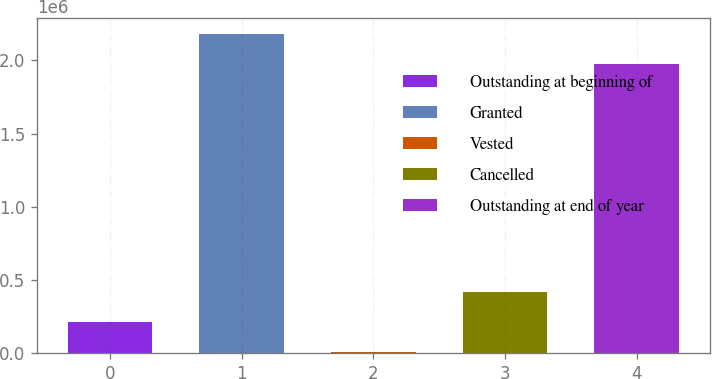Convert chart to OTSL. <chart><loc_0><loc_0><loc_500><loc_500><bar_chart><fcel>Outstanding at beginning of<fcel>Granted<fcel>Vested<fcel>Cancelled<fcel>Outstanding at end of year<nl><fcel>214689<fcel>2.18073e+06<fcel>12221<fcel>417157<fcel>1.97826e+06<nl></chart> 